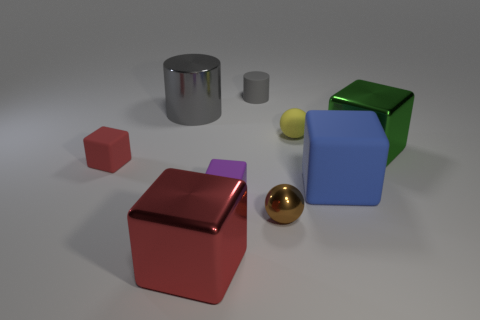Subtract all blue blocks. How many blocks are left? 4 Subtract all big blue matte cubes. How many cubes are left? 4 Add 1 gray matte objects. How many objects exist? 10 Subtract all yellow blocks. Subtract all purple spheres. How many blocks are left? 5 Subtract all blocks. How many objects are left? 4 Add 3 purple matte blocks. How many purple matte blocks exist? 4 Subtract 0 gray spheres. How many objects are left? 9 Subtract all small cyan metallic cubes. Subtract all large gray objects. How many objects are left? 8 Add 9 gray shiny cylinders. How many gray shiny cylinders are left? 10 